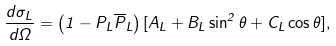Convert formula to latex. <formula><loc_0><loc_0><loc_500><loc_500>\frac { d \sigma _ { L } } { d \Omega } = \left ( 1 - P _ { L } \overline { P } _ { L } \right ) [ A _ { L } + B _ { L } \sin ^ { 2 } \theta + C _ { L } \cos \theta ] ,</formula> 